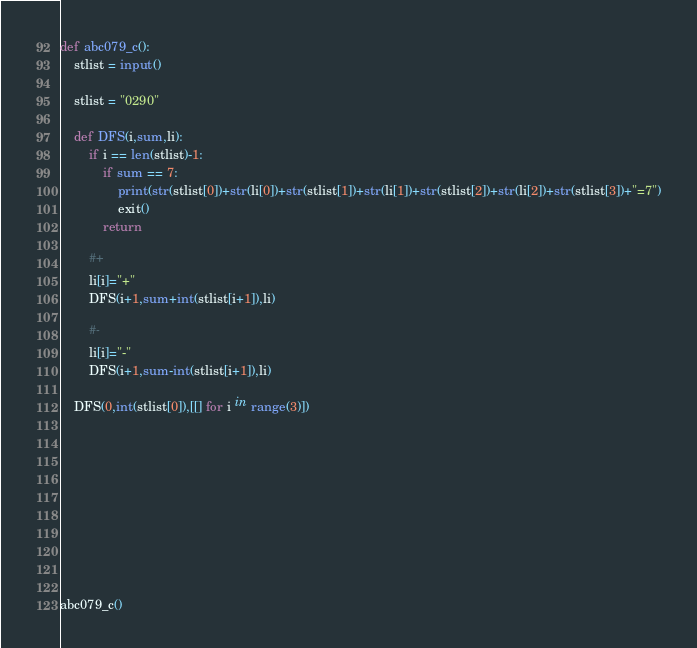<code> <loc_0><loc_0><loc_500><loc_500><_Python_>
def abc079_c():
    stlist = input()

    stlist = "0290"

    def DFS(i,sum,li):
        if i == len(stlist)-1:
            if sum == 7:
                print(str(stlist[0])+str(li[0])+str(stlist[1])+str(li[1])+str(stlist[2])+str(li[2])+str(stlist[3])+"=7")
                exit()
            return

        #+
        li[i]="+"
        DFS(i+1,sum+int(stlist[i+1]),li)

        #-
        li[i]="-"
        DFS(i+1,sum-int(stlist[i+1]),li)

    DFS(0,int(stlist[0]),[[] for i in range(3)])










abc079_c()
</code> 